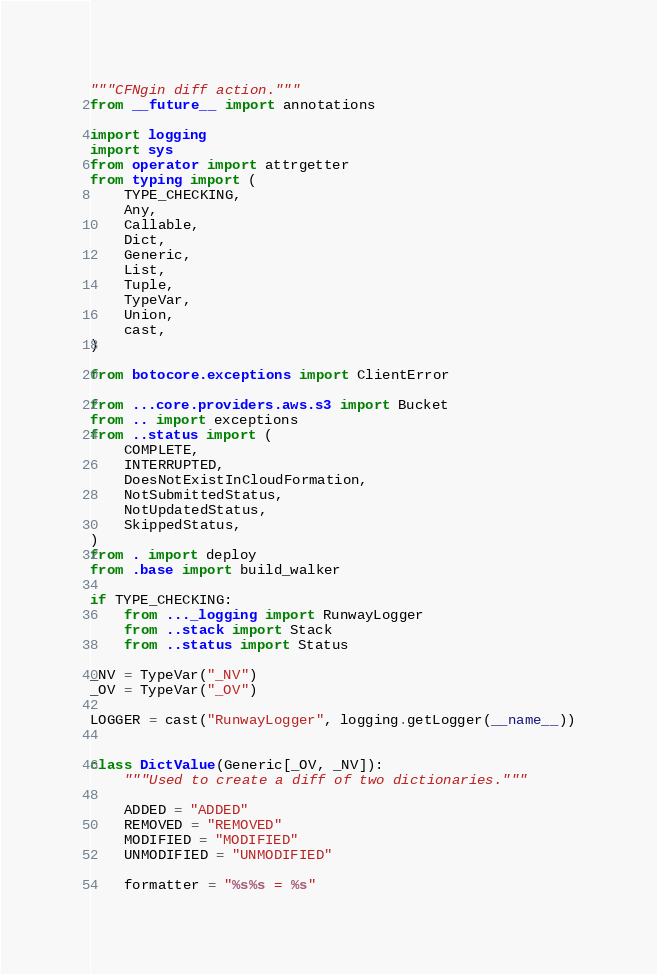<code> <loc_0><loc_0><loc_500><loc_500><_Python_>"""CFNgin diff action."""
from __future__ import annotations

import logging
import sys
from operator import attrgetter
from typing import (
    TYPE_CHECKING,
    Any,
    Callable,
    Dict,
    Generic,
    List,
    Tuple,
    TypeVar,
    Union,
    cast,
)

from botocore.exceptions import ClientError

from ...core.providers.aws.s3 import Bucket
from .. import exceptions
from ..status import (
    COMPLETE,
    INTERRUPTED,
    DoesNotExistInCloudFormation,
    NotSubmittedStatus,
    NotUpdatedStatus,
    SkippedStatus,
)
from . import deploy
from .base import build_walker

if TYPE_CHECKING:
    from ..._logging import RunwayLogger
    from ..stack import Stack
    from ..status import Status

_NV = TypeVar("_NV")
_OV = TypeVar("_OV")

LOGGER = cast("RunwayLogger", logging.getLogger(__name__))


class DictValue(Generic[_OV, _NV]):
    """Used to create a diff of two dictionaries."""

    ADDED = "ADDED"
    REMOVED = "REMOVED"
    MODIFIED = "MODIFIED"
    UNMODIFIED = "UNMODIFIED"

    formatter = "%s%s = %s"
</code> 